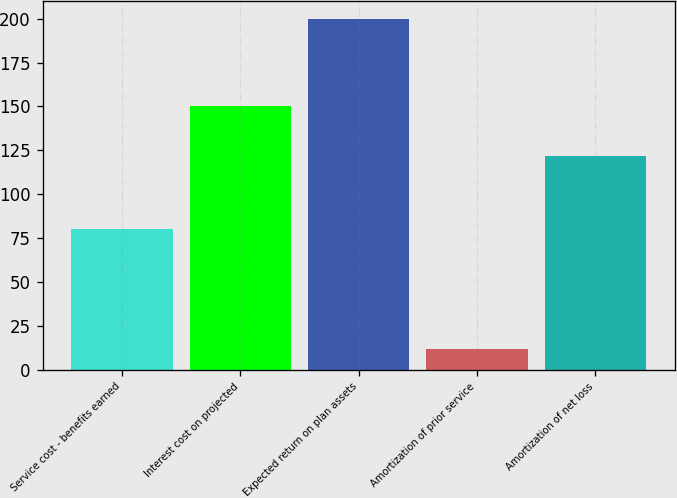Convert chart to OTSL. <chart><loc_0><loc_0><loc_500><loc_500><bar_chart><fcel>Service cost - benefits earned<fcel>Interest cost on projected<fcel>Expected return on plan assets<fcel>Amortization of prior service<fcel>Amortization of net loss<nl><fcel>80<fcel>150<fcel>200<fcel>12<fcel>122<nl></chart> 